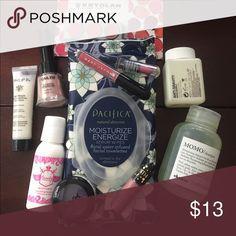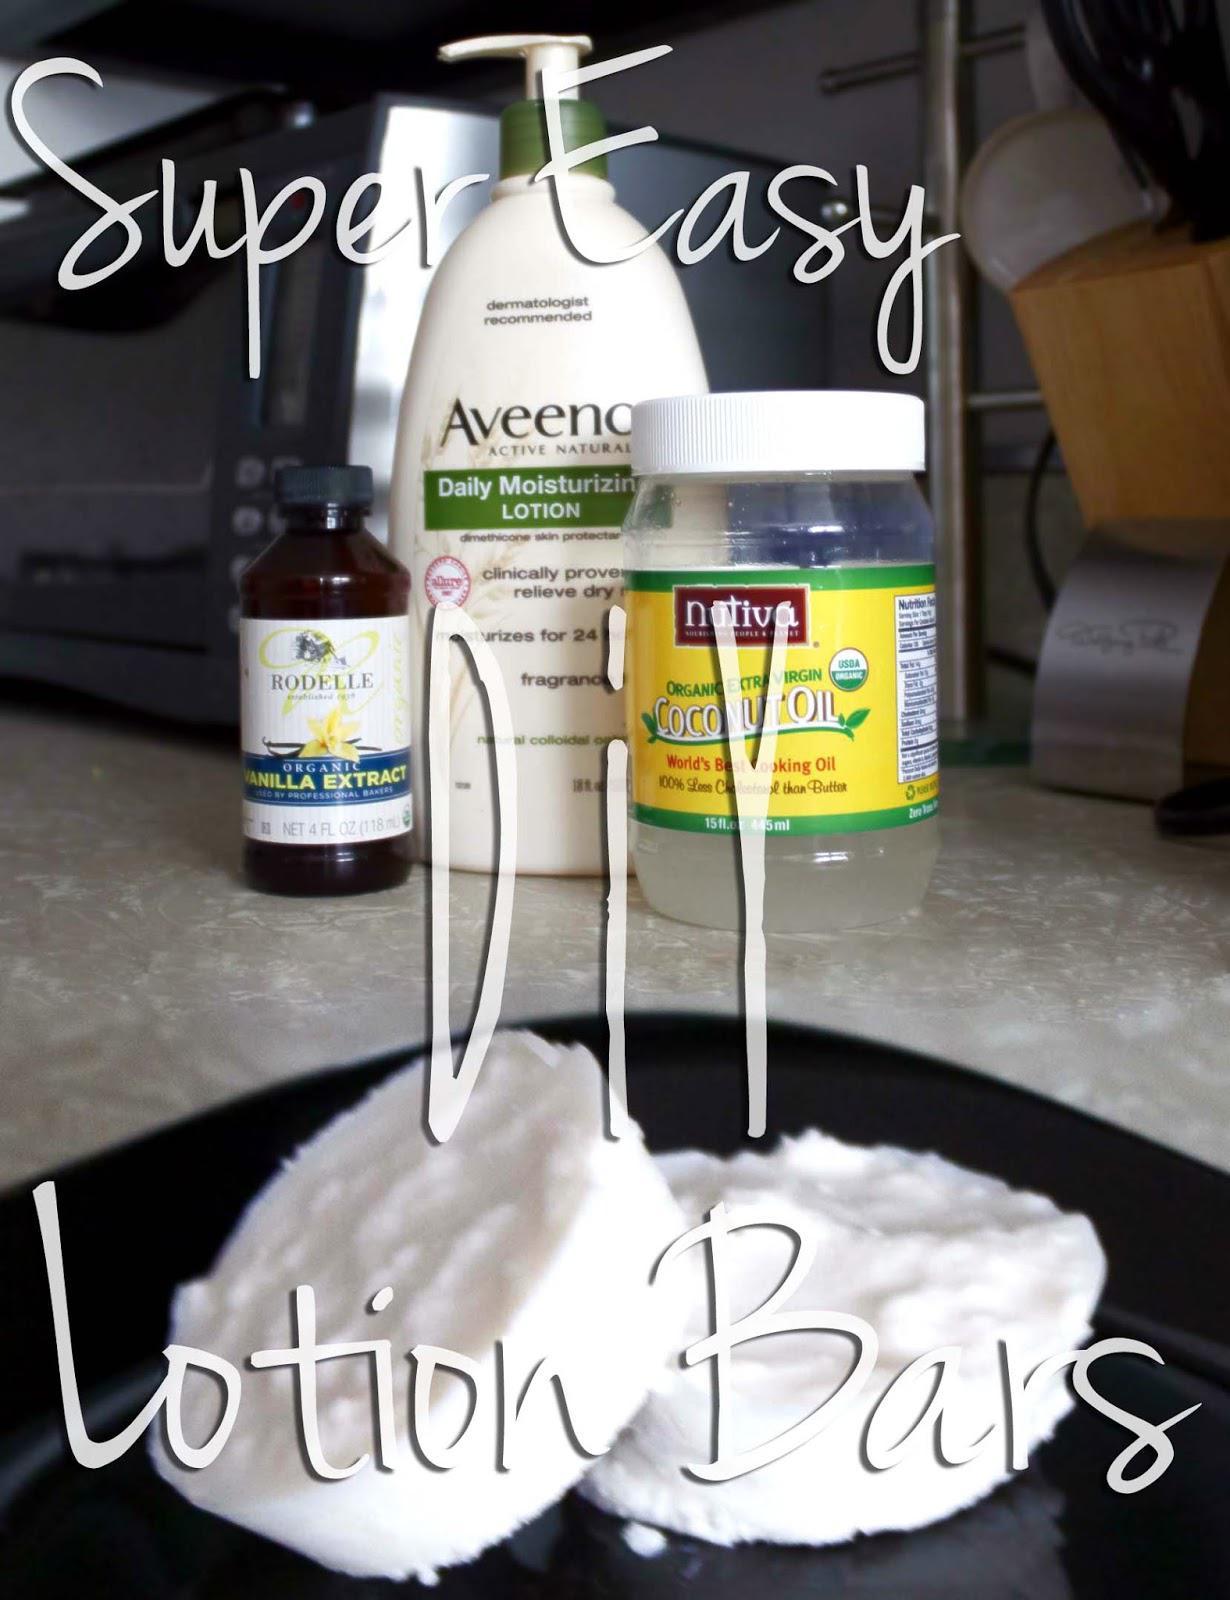The first image is the image on the left, the second image is the image on the right. Assess this claim about the two images: "The lotion in one of the images is sitting in round tin containers.". Correct or not? Answer yes or no. No. The first image is the image on the left, the second image is the image on the right. Examine the images to the left and right. Is the description "An image includes multiple stacks of short silver containers with labels on top, and with only one unlidded." accurate? Answer yes or no. No. 